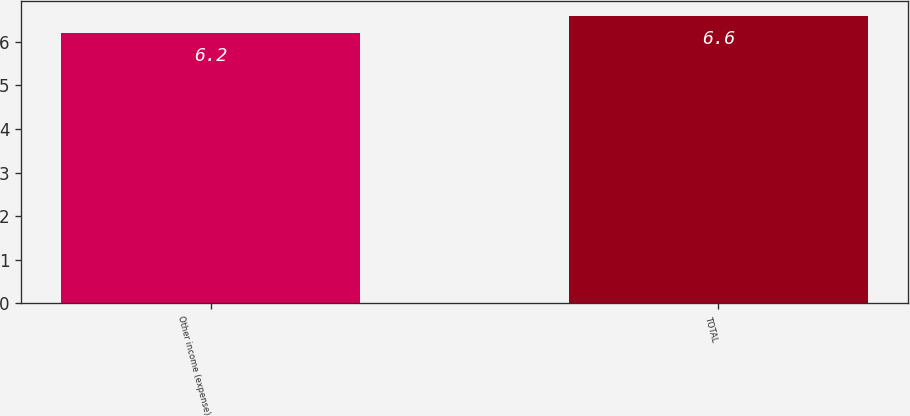Convert chart to OTSL. <chart><loc_0><loc_0><loc_500><loc_500><bar_chart><fcel>Other income (expense)<fcel>TOTAL<nl><fcel>6.2<fcel>6.6<nl></chart> 